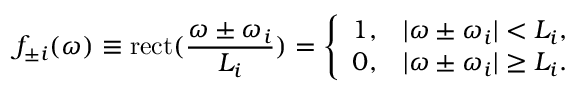<formula> <loc_0><loc_0><loc_500><loc_500>f _ { \pm i } ( \omega ) \equiv r e c t ( \frac { \omega \pm \omega _ { i } } { L _ { i } } ) = \left \{ \begin{array} { l l } { 1 , } & { | \omega \pm \omega _ { i } | < L _ { i } , } \\ { 0 , } & { | \omega \pm \omega _ { i } | \geq L _ { i } . } \end{array}</formula> 